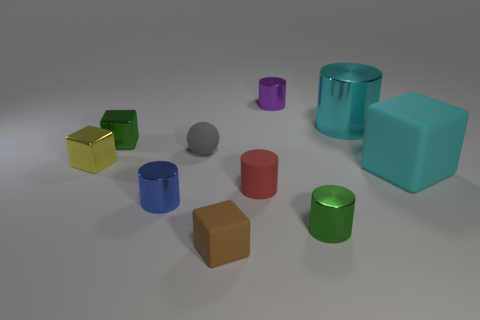Subtract all big rubber cubes. How many cubes are left? 3 Subtract 2 blocks. How many blocks are left? 2 Subtract all brown blocks. How many blocks are left? 3 Subtract 0 purple cubes. How many objects are left? 10 Subtract all spheres. How many objects are left? 9 Subtract all blue cubes. Subtract all brown cylinders. How many cubes are left? 4 Subtract all cyan cubes. How many purple balls are left? 0 Subtract all big cyan cubes. Subtract all gray metal objects. How many objects are left? 9 Add 9 tiny gray spheres. How many tiny gray spheres are left? 10 Add 6 tiny yellow matte cylinders. How many tiny yellow matte cylinders exist? 6 